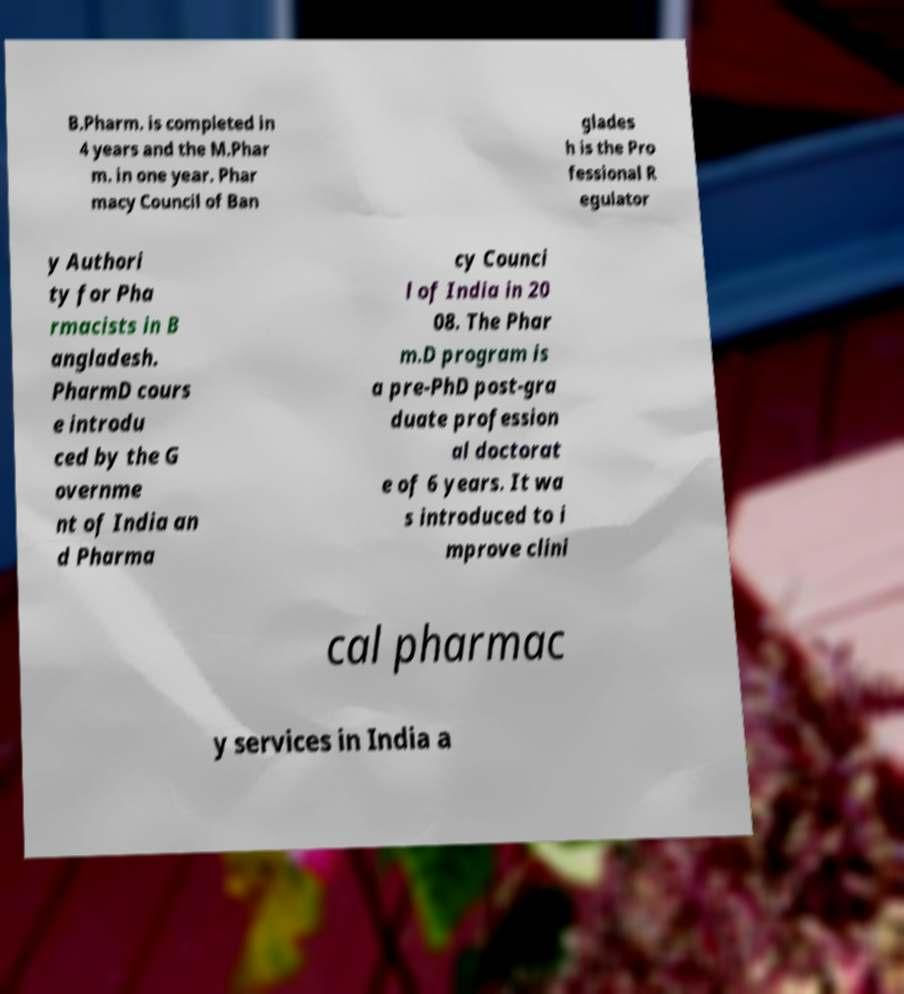Can you read and provide the text displayed in the image?This photo seems to have some interesting text. Can you extract and type it out for me? B.Pharm. is completed in 4 years and the M.Phar m. in one year. Phar macy Council of Ban glades h is the Pro fessional R egulator y Authori ty for Pha rmacists in B angladesh. PharmD cours e introdu ced by the G overnme nt of India an d Pharma cy Counci l of India in 20 08. The Phar m.D program is a pre-PhD post-gra duate profession al doctorat e of 6 years. It wa s introduced to i mprove clini cal pharmac y services in India a 